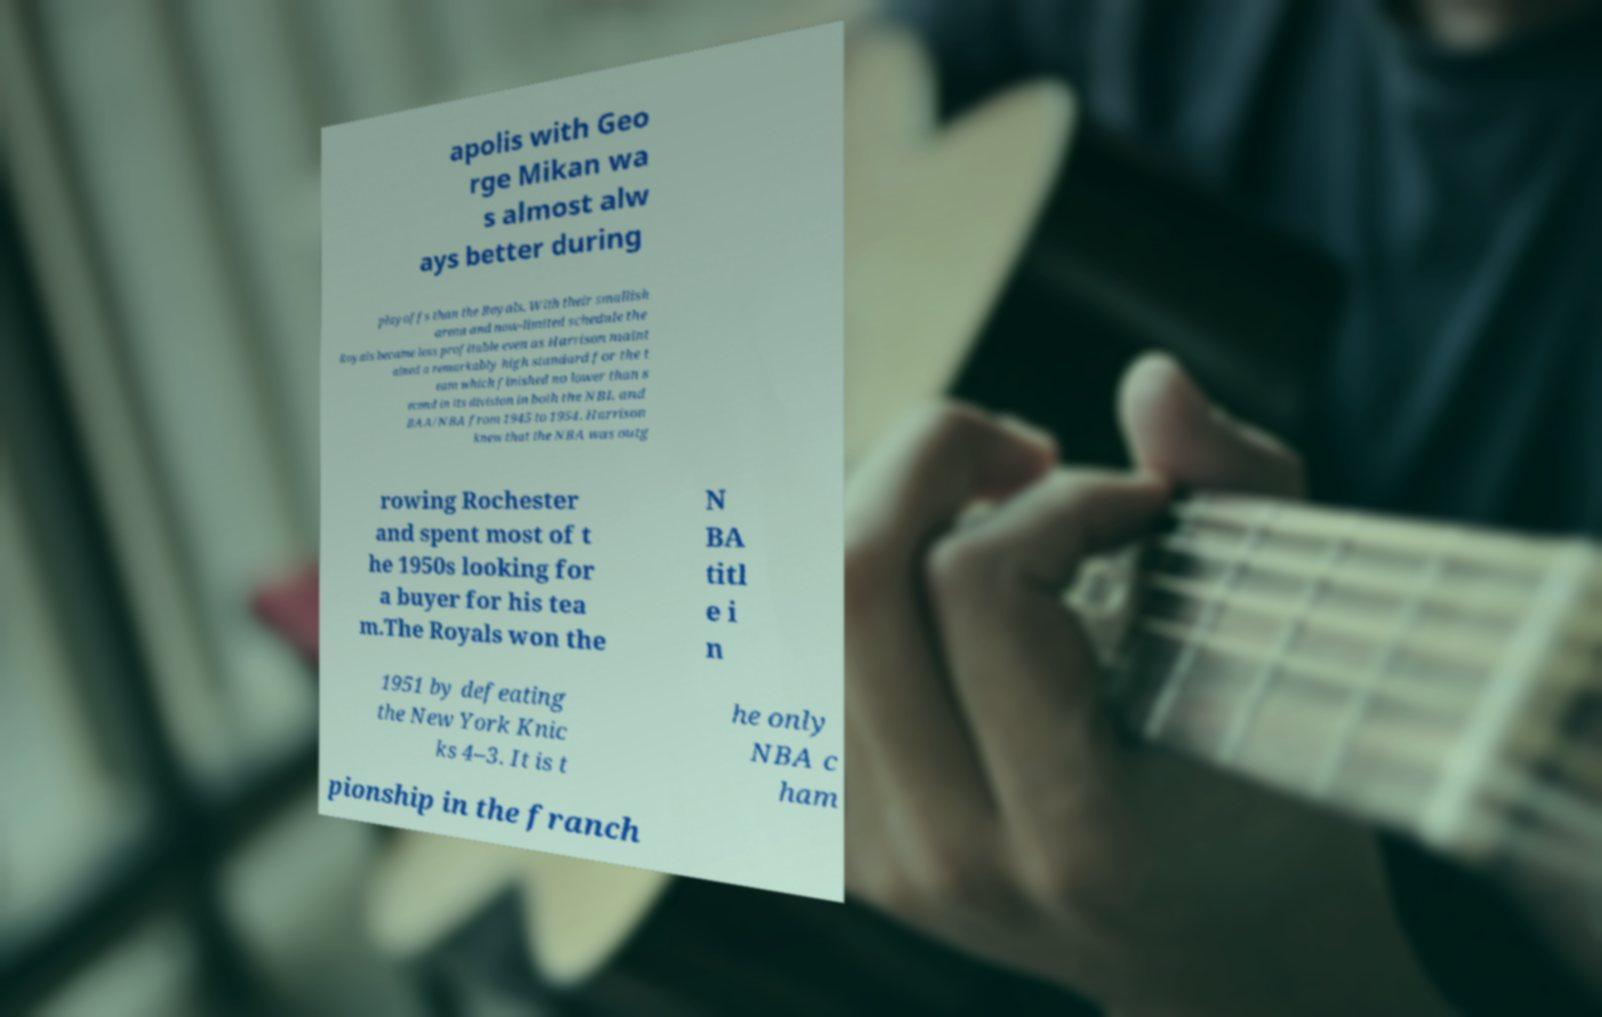Please read and relay the text visible in this image. What does it say? apolis with Geo rge Mikan wa s almost alw ays better during playoffs than the Royals. With their smallish arena and now-limited schedule the Royals became less profitable even as Harrison maint ained a remarkably high standard for the t eam which finished no lower than s econd in its division in both the NBL and BAA/NBA from 1945 to 1954. Harrison knew that the NBA was outg rowing Rochester and spent most of t he 1950s looking for a buyer for his tea m.The Royals won the N BA titl e i n 1951 by defeating the New York Knic ks 4–3. It is t he only NBA c ham pionship in the franch 